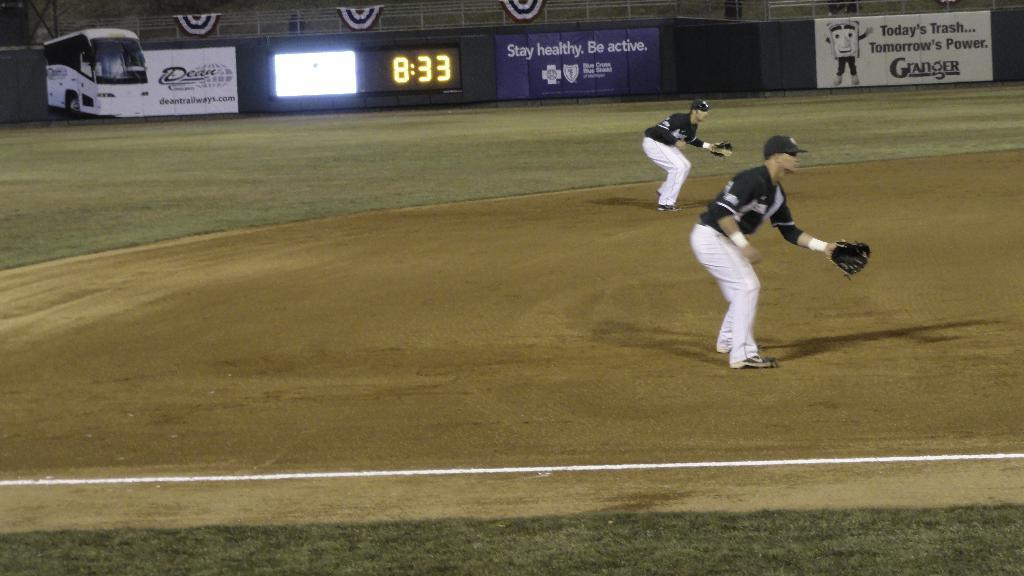How many people are in the image? There are two persons in the image. What are the persons wearing on their heads? Both persons are wearing caps. What can be seen in the background of the image? There are posters in the background of the image. What is the time shown on the digital watch in the image? The digital watch in the image is showing the time. What type of recreational area is visible in the image? There is a playground in the image. How many chickens are present in the image? There are no chickens present in the image. What type of house can be seen in the background of the image? There is no house visible in the background of the image. 